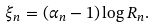<formula> <loc_0><loc_0><loc_500><loc_500>\xi _ { n } = ( \alpha _ { n } - 1 ) \log R _ { n } .</formula> 